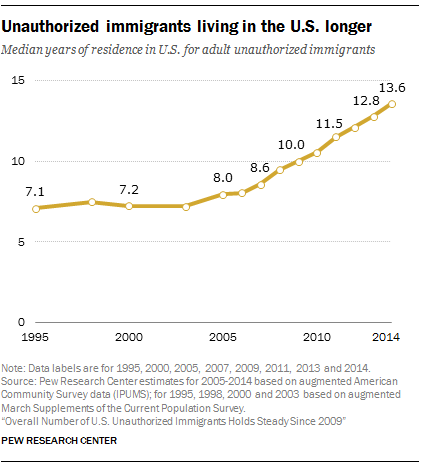Indicate a few pertinent items in this graphic. The sum of the first point and the largest value of the orange graph is 20.7. In 2014, the median years of residence in the United States for adult unauthorized immigrants was 13.6 years. 